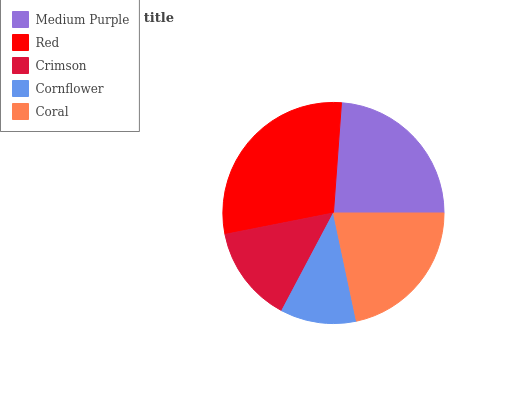Is Cornflower the minimum?
Answer yes or no. Yes. Is Red the maximum?
Answer yes or no. Yes. Is Crimson the minimum?
Answer yes or no. No. Is Crimson the maximum?
Answer yes or no. No. Is Red greater than Crimson?
Answer yes or no. Yes. Is Crimson less than Red?
Answer yes or no. Yes. Is Crimson greater than Red?
Answer yes or no. No. Is Red less than Crimson?
Answer yes or no. No. Is Coral the high median?
Answer yes or no. Yes. Is Coral the low median?
Answer yes or no. Yes. Is Crimson the high median?
Answer yes or no. No. Is Red the low median?
Answer yes or no. No. 